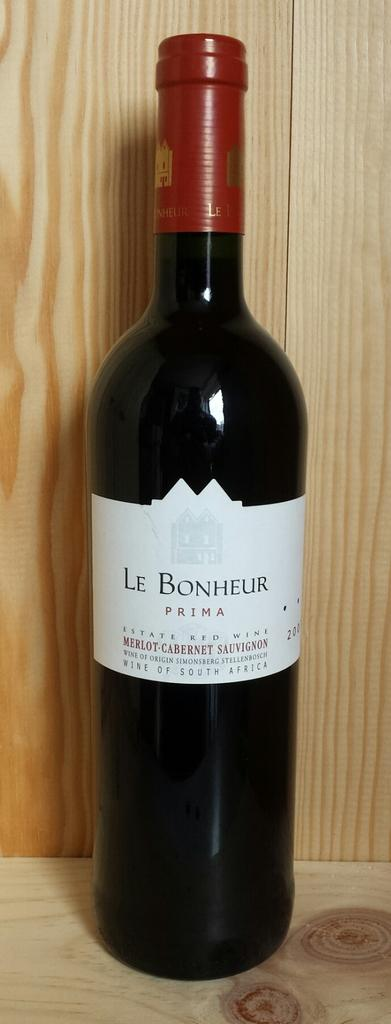<image>
Render a clear and concise summary of the photo. A bottle of "Le Bonheur" is on the table. 